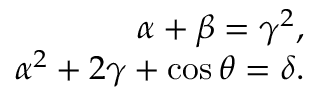<formula> <loc_0><loc_0><loc_500><loc_500>\begin{array} { r } { \alpha + \beta = \gamma ^ { 2 } , } \\ { \alpha ^ { 2 } + 2 \gamma + \cos \theta = \delta . } \end{array}</formula> 